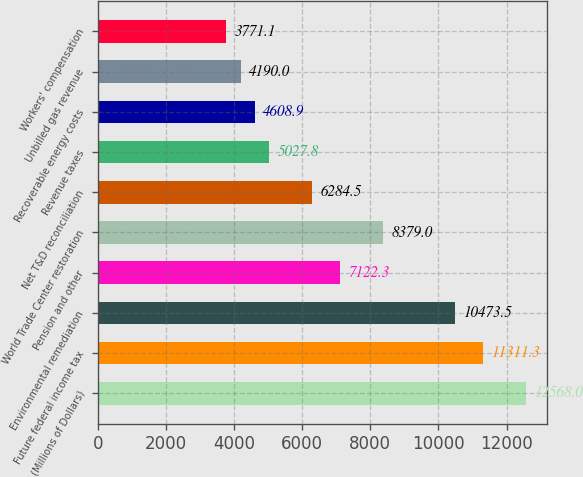<chart> <loc_0><loc_0><loc_500><loc_500><bar_chart><fcel>(Millions of Dollars)<fcel>Future federal income tax<fcel>Environmental remediation<fcel>Pension and other<fcel>World Trade Center restoration<fcel>Net T&D reconciliation<fcel>Revenue taxes<fcel>Recoverable energy costs<fcel>Unbilled gas revenue<fcel>Workers' compensation<nl><fcel>12568<fcel>11311.3<fcel>10473.5<fcel>7122.3<fcel>8379<fcel>6284.5<fcel>5027.8<fcel>4608.9<fcel>4190<fcel>3771.1<nl></chart> 